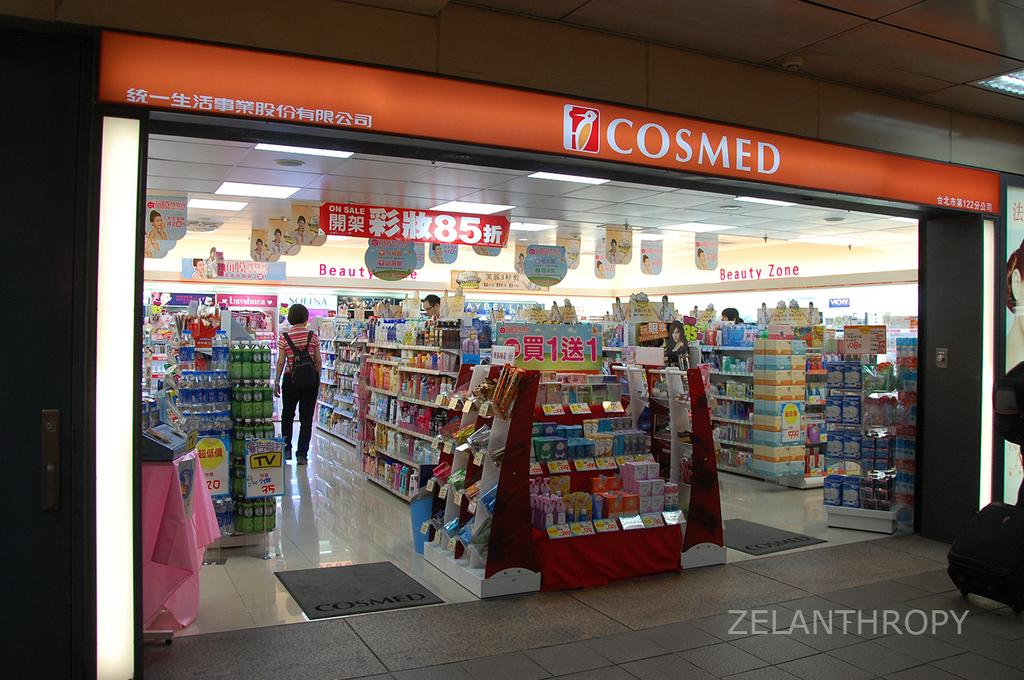<image>
Share a concise interpretation of the image provided. The front of a Cosmed store with many items inside of it. 